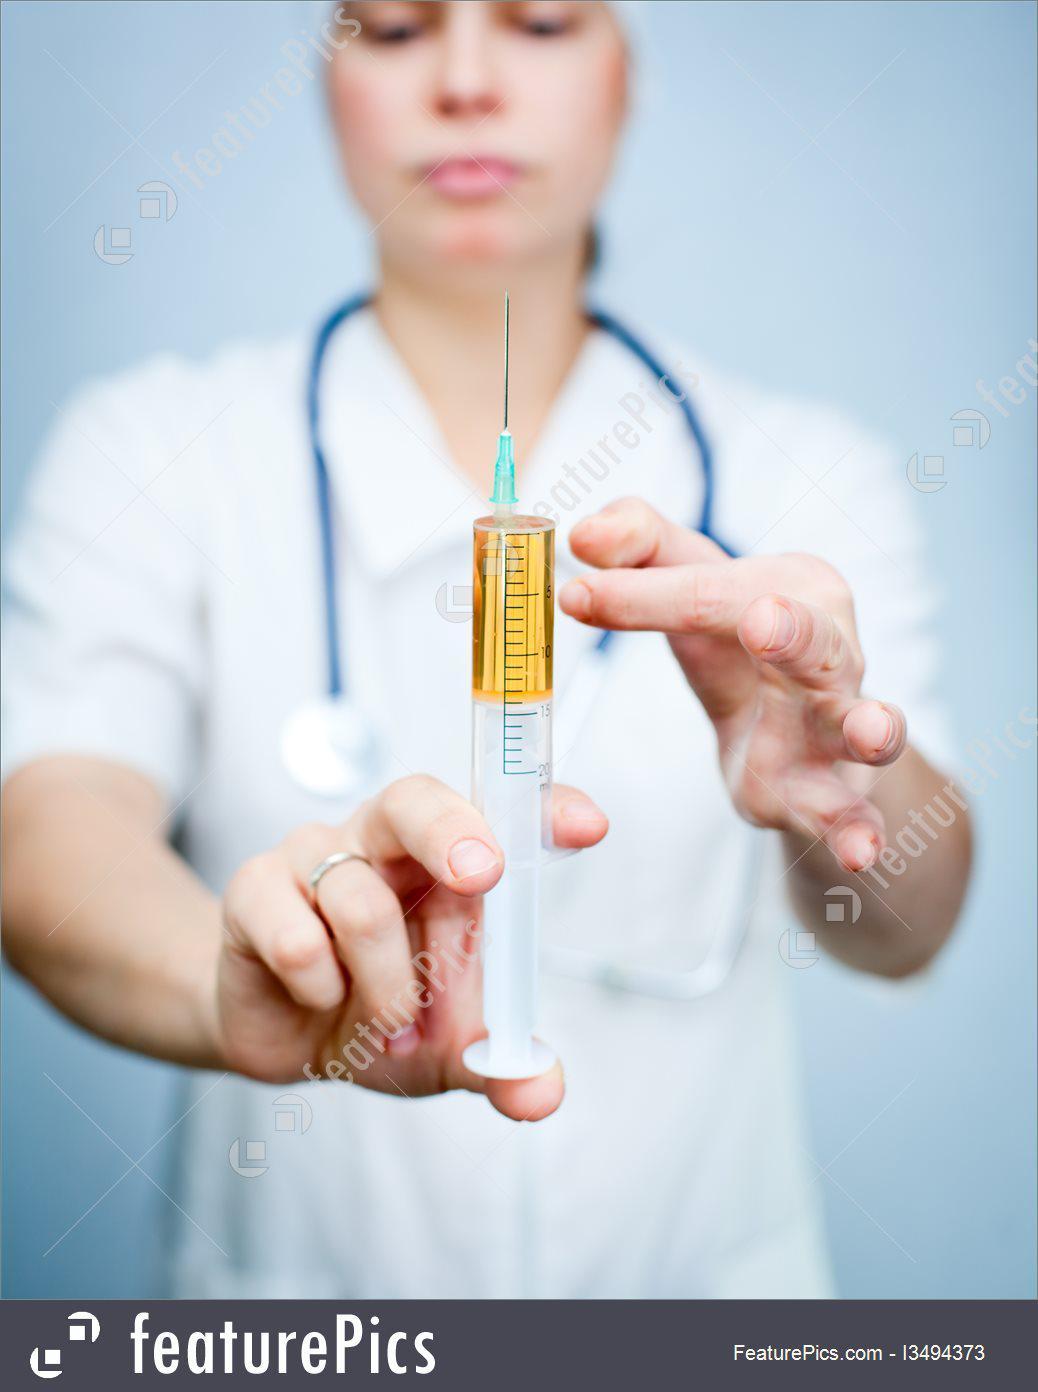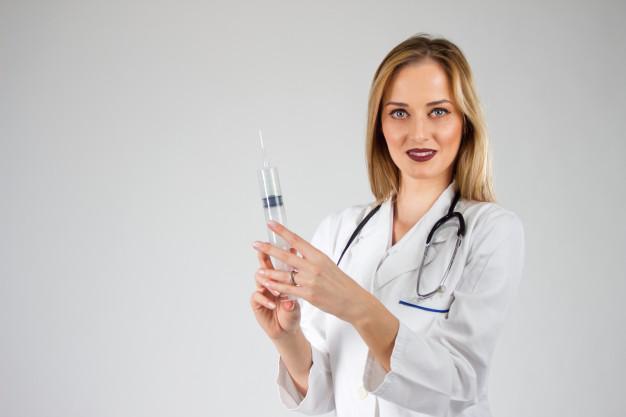The first image is the image on the left, the second image is the image on the right. Considering the images on both sides, is "In at least one of the images, a medical professional is looking directly at a syringe full of blue liquid." valid? Answer yes or no. No. The first image is the image on the left, the second image is the image on the right. Given the left and right images, does the statement "The left image shows a man holding up an aqua-colored syringe with one bare hand." hold true? Answer yes or no. No. 